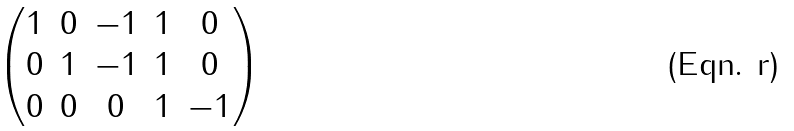<formula> <loc_0><loc_0><loc_500><loc_500>\begin{pmatrix} 1 & 0 & - 1 & 1 & 0 \\ 0 & 1 & - 1 & 1 & 0 \\ 0 & 0 & 0 & 1 & - 1 \end{pmatrix}</formula> 